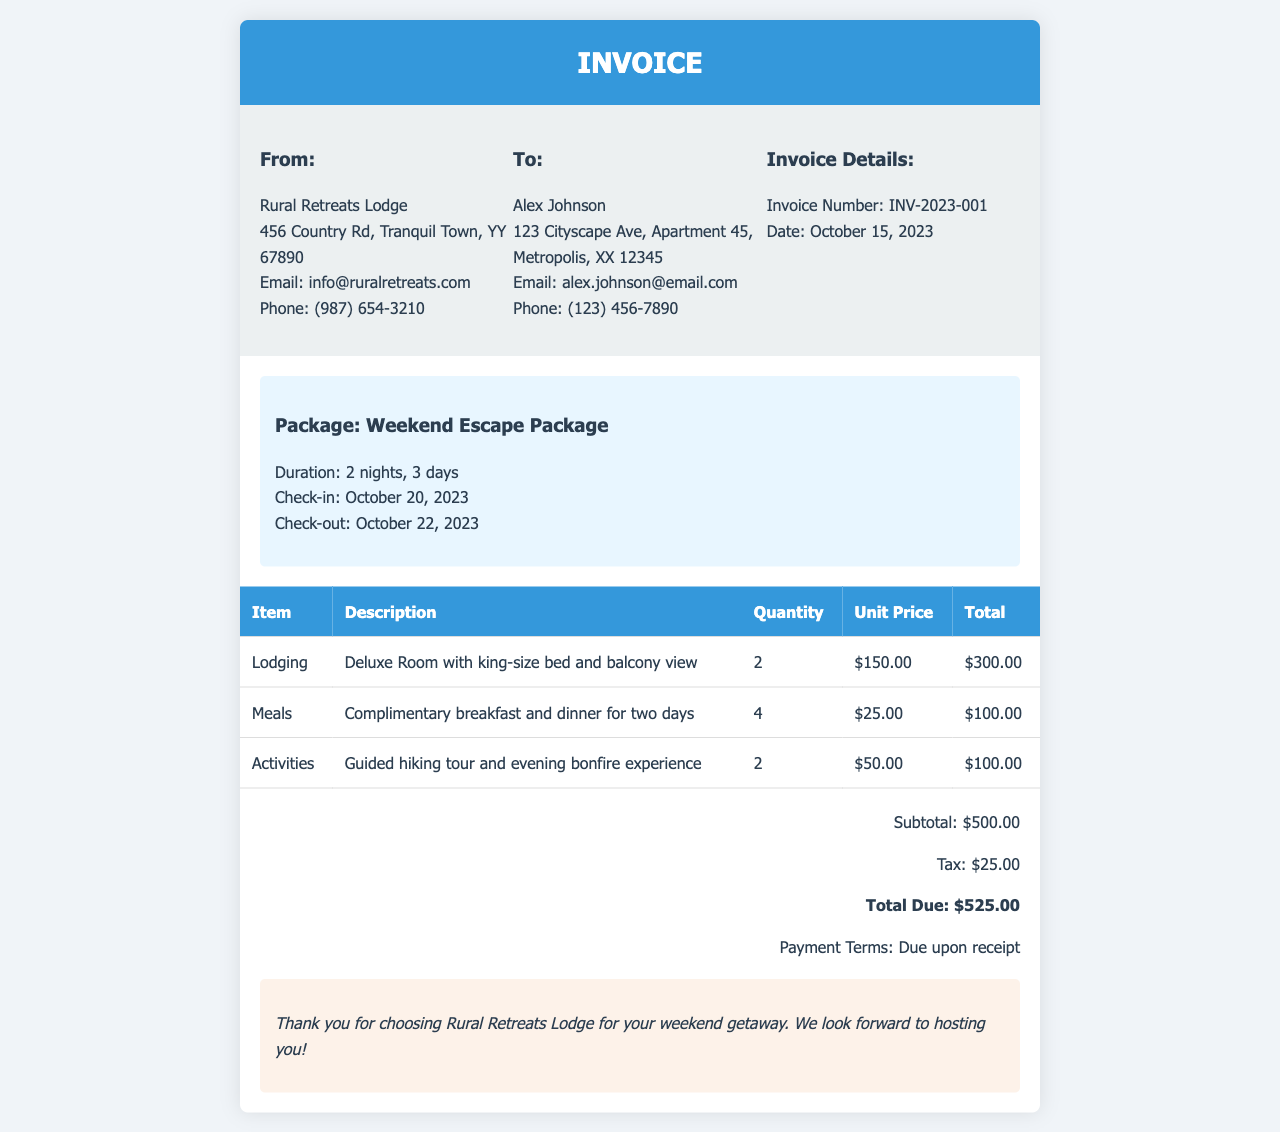What is the invoice number? The invoice number is specified in the "Invoice Details" section of the document.
Answer: INV-2023-001 What is the check-out date? The check-out date is mentioned in the package details section.
Answer: October 22, 2023 How many nights does the weekend getaway package include? The duration of the package is stated in the package details.
Answer: 2 nights What is the total due amount? The total due is indicated in the total section at the bottom of the invoice.
Answer: $525.00 What activities are included in the package? The activities are listed in the table under the "Activities" row.
Answer: Guided hiking tour and evening bonfire experience How much is the tax charged on the invoice? The tax amount is specified in the total section of the invoice.
Answer: $25.00 What is the unit price of lodging? The unit price is listed in the lodging row of the table.
Answer: $150.00 What type of meals are included? The type of meals is described in the meals row of the table.
Answer: Complimentary breakfast and dinner for two days Who is the invoice addressed to? The recipient of the invoice is specified in the "To" section.
Answer: Alex Johnson 